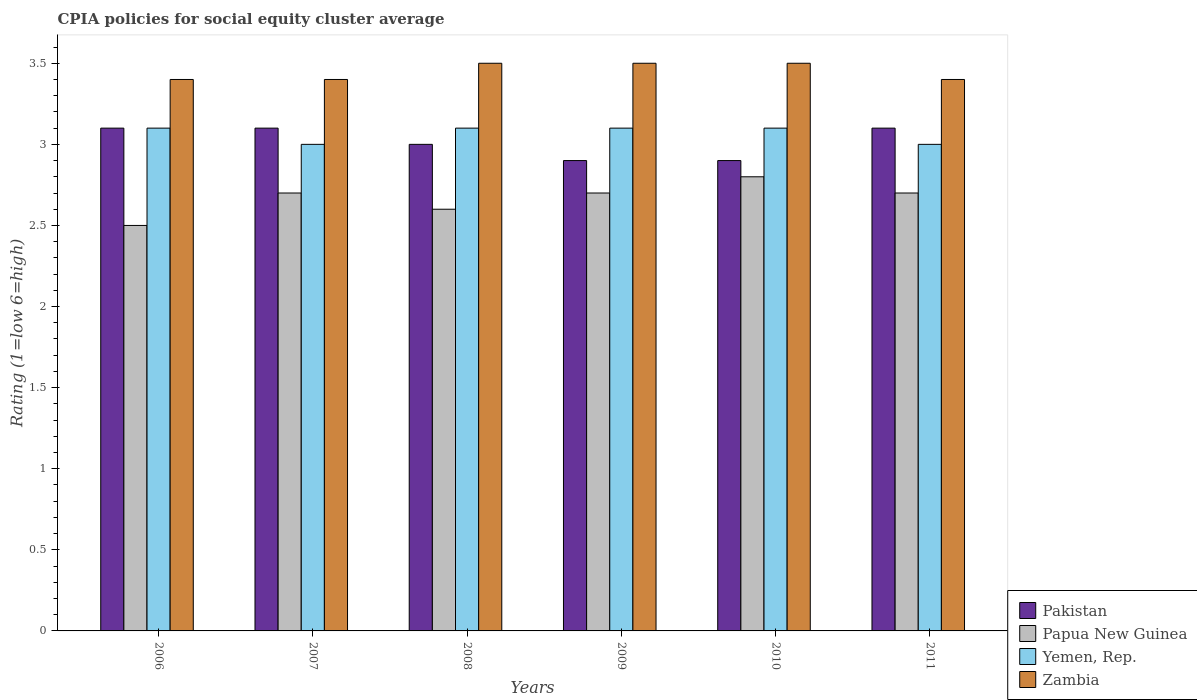How many different coloured bars are there?
Your response must be concise. 4. Are the number of bars per tick equal to the number of legend labels?
Ensure brevity in your answer.  Yes. How many bars are there on the 4th tick from the left?
Make the answer very short. 4. How many bars are there on the 3rd tick from the right?
Your answer should be very brief. 4. In how many cases, is the number of bars for a given year not equal to the number of legend labels?
Your answer should be very brief. 0. Across all years, what is the maximum CPIA rating in Zambia?
Offer a terse response. 3.5. In which year was the CPIA rating in Papua New Guinea minimum?
Keep it short and to the point. 2006. What is the total CPIA rating in Yemen, Rep. in the graph?
Offer a terse response. 18.4. What is the difference between the CPIA rating in Pakistan in 2011 and the CPIA rating in Papua New Guinea in 2009?
Ensure brevity in your answer.  0.4. What is the average CPIA rating in Papua New Guinea per year?
Your answer should be compact. 2.67. In the year 2008, what is the difference between the CPIA rating in Pakistan and CPIA rating in Papua New Guinea?
Your answer should be very brief. 0.4. In how many years, is the CPIA rating in Papua New Guinea greater than 3.5?
Give a very brief answer. 0. Is the CPIA rating in Yemen, Rep. in 2006 less than that in 2010?
Provide a succinct answer. No. Is the difference between the CPIA rating in Pakistan in 2008 and 2009 greater than the difference between the CPIA rating in Papua New Guinea in 2008 and 2009?
Offer a very short reply. Yes. What is the difference between the highest and the lowest CPIA rating in Zambia?
Your answer should be very brief. 0.1. What does the 1st bar from the left in 2006 represents?
Your answer should be compact. Pakistan. What does the 2nd bar from the right in 2006 represents?
Give a very brief answer. Yemen, Rep. How many bars are there?
Give a very brief answer. 24. What is the difference between two consecutive major ticks on the Y-axis?
Your response must be concise. 0.5. Are the values on the major ticks of Y-axis written in scientific E-notation?
Provide a succinct answer. No. Does the graph contain grids?
Provide a short and direct response. No. Where does the legend appear in the graph?
Your response must be concise. Bottom right. What is the title of the graph?
Make the answer very short. CPIA policies for social equity cluster average. What is the label or title of the Y-axis?
Provide a short and direct response. Rating (1=low 6=high). What is the Rating (1=low 6=high) in Papua New Guinea in 2006?
Your answer should be compact. 2.5. What is the Rating (1=low 6=high) in Zambia in 2006?
Your answer should be compact. 3.4. What is the Rating (1=low 6=high) in Pakistan in 2007?
Provide a succinct answer. 3.1. What is the Rating (1=low 6=high) of Papua New Guinea in 2007?
Your answer should be very brief. 2.7. What is the Rating (1=low 6=high) of Yemen, Rep. in 2007?
Offer a terse response. 3. What is the Rating (1=low 6=high) in Zambia in 2007?
Offer a very short reply. 3.4. What is the Rating (1=low 6=high) of Pakistan in 2008?
Keep it short and to the point. 3. What is the Rating (1=low 6=high) of Yemen, Rep. in 2010?
Provide a succinct answer. 3.1. What is the Rating (1=low 6=high) of Zambia in 2010?
Ensure brevity in your answer.  3.5. What is the Rating (1=low 6=high) in Yemen, Rep. in 2011?
Give a very brief answer. 3. What is the Rating (1=low 6=high) of Zambia in 2011?
Provide a short and direct response. 3.4. Across all years, what is the maximum Rating (1=low 6=high) of Zambia?
Provide a succinct answer. 3.5. Across all years, what is the minimum Rating (1=low 6=high) in Pakistan?
Your answer should be compact. 2.9. Across all years, what is the minimum Rating (1=low 6=high) of Papua New Guinea?
Offer a terse response. 2.5. Across all years, what is the minimum Rating (1=low 6=high) in Yemen, Rep.?
Offer a terse response. 3. What is the total Rating (1=low 6=high) of Yemen, Rep. in the graph?
Offer a terse response. 18.4. What is the total Rating (1=low 6=high) in Zambia in the graph?
Provide a short and direct response. 20.7. What is the difference between the Rating (1=low 6=high) of Pakistan in 2006 and that in 2007?
Keep it short and to the point. 0. What is the difference between the Rating (1=low 6=high) in Zambia in 2006 and that in 2007?
Ensure brevity in your answer.  0. What is the difference between the Rating (1=low 6=high) of Yemen, Rep. in 2006 and that in 2008?
Ensure brevity in your answer.  0. What is the difference between the Rating (1=low 6=high) in Zambia in 2006 and that in 2008?
Your answer should be very brief. -0.1. What is the difference between the Rating (1=low 6=high) of Pakistan in 2006 and that in 2009?
Offer a very short reply. 0.2. What is the difference between the Rating (1=low 6=high) in Zambia in 2006 and that in 2009?
Provide a succinct answer. -0.1. What is the difference between the Rating (1=low 6=high) in Yemen, Rep. in 2006 and that in 2010?
Provide a succinct answer. 0. What is the difference between the Rating (1=low 6=high) in Pakistan in 2006 and that in 2011?
Provide a short and direct response. 0. What is the difference between the Rating (1=low 6=high) in Papua New Guinea in 2006 and that in 2011?
Keep it short and to the point. -0.2. What is the difference between the Rating (1=low 6=high) of Zambia in 2006 and that in 2011?
Ensure brevity in your answer.  0. What is the difference between the Rating (1=low 6=high) of Papua New Guinea in 2007 and that in 2008?
Give a very brief answer. 0.1. What is the difference between the Rating (1=low 6=high) of Yemen, Rep. in 2007 and that in 2008?
Your response must be concise. -0.1. What is the difference between the Rating (1=low 6=high) in Pakistan in 2007 and that in 2009?
Provide a succinct answer. 0.2. What is the difference between the Rating (1=low 6=high) of Yemen, Rep. in 2007 and that in 2009?
Ensure brevity in your answer.  -0.1. What is the difference between the Rating (1=low 6=high) of Pakistan in 2007 and that in 2010?
Your answer should be compact. 0.2. What is the difference between the Rating (1=low 6=high) of Papua New Guinea in 2007 and that in 2010?
Offer a terse response. -0.1. What is the difference between the Rating (1=low 6=high) in Yemen, Rep. in 2007 and that in 2011?
Your answer should be compact. 0. What is the difference between the Rating (1=low 6=high) in Yemen, Rep. in 2008 and that in 2009?
Make the answer very short. 0. What is the difference between the Rating (1=low 6=high) in Pakistan in 2008 and that in 2010?
Offer a very short reply. 0.1. What is the difference between the Rating (1=low 6=high) of Papua New Guinea in 2008 and that in 2010?
Your answer should be compact. -0.2. What is the difference between the Rating (1=low 6=high) of Papua New Guinea in 2008 and that in 2011?
Ensure brevity in your answer.  -0.1. What is the difference between the Rating (1=low 6=high) of Yemen, Rep. in 2008 and that in 2011?
Give a very brief answer. 0.1. What is the difference between the Rating (1=low 6=high) of Zambia in 2008 and that in 2011?
Your answer should be very brief. 0.1. What is the difference between the Rating (1=low 6=high) in Yemen, Rep. in 2009 and that in 2010?
Offer a very short reply. 0. What is the difference between the Rating (1=low 6=high) of Yemen, Rep. in 2009 and that in 2011?
Offer a very short reply. 0.1. What is the difference between the Rating (1=low 6=high) of Papua New Guinea in 2010 and that in 2011?
Your answer should be compact. 0.1. What is the difference between the Rating (1=low 6=high) of Papua New Guinea in 2006 and the Rating (1=low 6=high) of Yemen, Rep. in 2007?
Your response must be concise. -0.5. What is the difference between the Rating (1=low 6=high) in Pakistan in 2006 and the Rating (1=low 6=high) in Yemen, Rep. in 2008?
Keep it short and to the point. 0. What is the difference between the Rating (1=low 6=high) of Pakistan in 2006 and the Rating (1=low 6=high) of Zambia in 2008?
Your response must be concise. -0.4. What is the difference between the Rating (1=low 6=high) in Papua New Guinea in 2006 and the Rating (1=low 6=high) in Zambia in 2008?
Provide a succinct answer. -1. What is the difference between the Rating (1=low 6=high) of Yemen, Rep. in 2006 and the Rating (1=low 6=high) of Zambia in 2008?
Keep it short and to the point. -0.4. What is the difference between the Rating (1=low 6=high) in Pakistan in 2006 and the Rating (1=low 6=high) in Papua New Guinea in 2009?
Offer a terse response. 0.4. What is the difference between the Rating (1=low 6=high) in Pakistan in 2006 and the Rating (1=low 6=high) in Yemen, Rep. in 2009?
Ensure brevity in your answer.  0. What is the difference between the Rating (1=low 6=high) in Pakistan in 2006 and the Rating (1=low 6=high) in Zambia in 2009?
Ensure brevity in your answer.  -0.4. What is the difference between the Rating (1=low 6=high) of Papua New Guinea in 2006 and the Rating (1=low 6=high) of Yemen, Rep. in 2009?
Offer a terse response. -0.6. What is the difference between the Rating (1=low 6=high) of Papua New Guinea in 2006 and the Rating (1=low 6=high) of Zambia in 2009?
Offer a terse response. -1. What is the difference between the Rating (1=low 6=high) of Yemen, Rep. in 2006 and the Rating (1=low 6=high) of Zambia in 2009?
Provide a succinct answer. -0.4. What is the difference between the Rating (1=low 6=high) of Pakistan in 2006 and the Rating (1=low 6=high) of Yemen, Rep. in 2010?
Provide a succinct answer. 0. What is the difference between the Rating (1=low 6=high) of Papua New Guinea in 2006 and the Rating (1=low 6=high) of Yemen, Rep. in 2010?
Provide a succinct answer. -0.6. What is the difference between the Rating (1=low 6=high) of Papua New Guinea in 2006 and the Rating (1=low 6=high) of Zambia in 2010?
Make the answer very short. -1. What is the difference between the Rating (1=low 6=high) in Pakistan in 2006 and the Rating (1=low 6=high) in Yemen, Rep. in 2011?
Provide a succinct answer. 0.1. What is the difference between the Rating (1=low 6=high) of Yemen, Rep. in 2006 and the Rating (1=low 6=high) of Zambia in 2011?
Keep it short and to the point. -0.3. What is the difference between the Rating (1=low 6=high) in Pakistan in 2007 and the Rating (1=low 6=high) in Yemen, Rep. in 2008?
Make the answer very short. 0. What is the difference between the Rating (1=low 6=high) in Papua New Guinea in 2007 and the Rating (1=low 6=high) in Yemen, Rep. in 2008?
Offer a very short reply. -0.4. What is the difference between the Rating (1=low 6=high) of Papua New Guinea in 2007 and the Rating (1=low 6=high) of Zambia in 2008?
Offer a very short reply. -0.8. What is the difference between the Rating (1=low 6=high) of Yemen, Rep. in 2007 and the Rating (1=low 6=high) of Zambia in 2008?
Your answer should be compact. -0.5. What is the difference between the Rating (1=low 6=high) of Pakistan in 2007 and the Rating (1=low 6=high) of Papua New Guinea in 2009?
Your answer should be very brief. 0.4. What is the difference between the Rating (1=low 6=high) in Pakistan in 2007 and the Rating (1=low 6=high) in Yemen, Rep. in 2009?
Your answer should be compact. 0. What is the difference between the Rating (1=low 6=high) in Pakistan in 2007 and the Rating (1=low 6=high) in Zambia in 2009?
Your answer should be very brief. -0.4. What is the difference between the Rating (1=low 6=high) of Papua New Guinea in 2007 and the Rating (1=low 6=high) of Yemen, Rep. in 2009?
Provide a short and direct response. -0.4. What is the difference between the Rating (1=low 6=high) in Yemen, Rep. in 2007 and the Rating (1=low 6=high) in Zambia in 2009?
Make the answer very short. -0.5. What is the difference between the Rating (1=low 6=high) in Pakistan in 2007 and the Rating (1=low 6=high) in Yemen, Rep. in 2010?
Ensure brevity in your answer.  0. What is the difference between the Rating (1=low 6=high) of Yemen, Rep. in 2007 and the Rating (1=low 6=high) of Zambia in 2010?
Make the answer very short. -0.5. What is the difference between the Rating (1=low 6=high) in Pakistan in 2007 and the Rating (1=low 6=high) in Papua New Guinea in 2011?
Your response must be concise. 0.4. What is the difference between the Rating (1=low 6=high) of Pakistan in 2007 and the Rating (1=low 6=high) of Zambia in 2011?
Your response must be concise. -0.3. What is the difference between the Rating (1=low 6=high) in Papua New Guinea in 2007 and the Rating (1=low 6=high) in Zambia in 2011?
Provide a succinct answer. -0.7. What is the difference between the Rating (1=low 6=high) of Pakistan in 2008 and the Rating (1=low 6=high) of Papua New Guinea in 2009?
Ensure brevity in your answer.  0.3. What is the difference between the Rating (1=low 6=high) in Pakistan in 2008 and the Rating (1=low 6=high) in Zambia in 2009?
Provide a short and direct response. -0.5. What is the difference between the Rating (1=low 6=high) of Papua New Guinea in 2008 and the Rating (1=low 6=high) of Yemen, Rep. in 2009?
Your answer should be compact. -0.5. What is the difference between the Rating (1=low 6=high) in Papua New Guinea in 2008 and the Rating (1=low 6=high) in Zambia in 2009?
Offer a very short reply. -0.9. What is the difference between the Rating (1=low 6=high) of Yemen, Rep. in 2008 and the Rating (1=low 6=high) of Zambia in 2009?
Give a very brief answer. -0.4. What is the difference between the Rating (1=low 6=high) in Pakistan in 2008 and the Rating (1=low 6=high) in Papua New Guinea in 2010?
Your response must be concise. 0.2. What is the difference between the Rating (1=low 6=high) of Pakistan in 2008 and the Rating (1=low 6=high) of Yemen, Rep. in 2010?
Provide a succinct answer. -0.1. What is the difference between the Rating (1=low 6=high) of Pakistan in 2008 and the Rating (1=low 6=high) of Zambia in 2010?
Keep it short and to the point. -0.5. What is the difference between the Rating (1=low 6=high) in Papua New Guinea in 2008 and the Rating (1=low 6=high) in Yemen, Rep. in 2010?
Provide a short and direct response. -0.5. What is the difference between the Rating (1=low 6=high) in Papua New Guinea in 2008 and the Rating (1=low 6=high) in Zambia in 2010?
Your answer should be very brief. -0.9. What is the difference between the Rating (1=low 6=high) in Yemen, Rep. in 2008 and the Rating (1=low 6=high) in Zambia in 2010?
Your answer should be very brief. -0.4. What is the difference between the Rating (1=low 6=high) of Pakistan in 2008 and the Rating (1=low 6=high) of Papua New Guinea in 2011?
Give a very brief answer. 0.3. What is the difference between the Rating (1=low 6=high) of Pakistan in 2008 and the Rating (1=low 6=high) of Zambia in 2011?
Offer a terse response. -0.4. What is the difference between the Rating (1=low 6=high) in Papua New Guinea in 2008 and the Rating (1=low 6=high) in Zambia in 2011?
Offer a terse response. -0.8. What is the difference between the Rating (1=low 6=high) of Pakistan in 2009 and the Rating (1=low 6=high) of Papua New Guinea in 2010?
Ensure brevity in your answer.  0.1. What is the difference between the Rating (1=low 6=high) of Pakistan in 2009 and the Rating (1=low 6=high) of Yemen, Rep. in 2010?
Your response must be concise. -0.2. What is the difference between the Rating (1=low 6=high) in Pakistan in 2009 and the Rating (1=low 6=high) in Zambia in 2010?
Offer a terse response. -0.6. What is the difference between the Rating (1=low 6=high) of Papua New Guinea in 2009 and the Rating (1=low 6=high) of Zambia in 2010?
Give a very brief answer. -0.8. What is the difference between the Rating (1=low 6=high) of Papua New Guinea in 2009 and the Rating (1=low 6=high) of Yemen, Rep. in 2011?
Offer a terse response. -0.3. What is the difference between the Rating (1=low 6=high) of Pakistan in 2010 and the Rating (1=low 6=high) of Zambia in 2011?
Offer a terse response. -0.5. What is the average Rating (1=low 6=high) in Pakistan per year?
Offer a very short reply. 3.02. What is the average Rating (1=low 6=high) of Papua New Guinea per year?
Keep it short and to the point. 2.67. What is the average Rating (1=low 6=high) of Yemen, Rep. per year?
Make the answer very short. 3.07. What is the average Rating (1=low 6=high) of Zambia per year?
Give a very brief answer. 3.45. In the year 2006, what is the difference between the Rating (1=low 6=high) in Pakistan and Rating (1=low 6=high) in Zambia?
Keep it short and to the point. -0.3. In the year 2006, what is the difference between the Rating (1=low 6=high) in Papua New Guinea and Rating (1=low 6=high) in Yemen, Rep.?
Your answer should be compact. -0.6. In the year 2006, what is the difference between the Rating (1=low 6=high) of Yemen, Rep. and Rating (1=low 6=high) of Zambia?
Give a very brief answer. -0.3. In the year 2008, what is the difference between the Rating (1=low 6=high) of Pakistan and Rating (1=low 6=high) of Papua New Guinea?
Give a very brief answer. 0.4. In the year 2008, what is the difference between the Rating (1=low 6=high) of Papua New Guinea and Rating (1=low 6=high) of Yemen, Rep.?
Offer a very short reply. -0.5. In the year 2008, what is the difference between the Rating (1=low 6=high) in Papua New Guinea and Rating (1=low 6=high) in Zambia?
Provide a succinct answer. -0.9. In the year 2008, what is the difference between the Rating (1=low 6=high) of Yemen, Rep. and Rating (1=low 6=high) of Zambia?
Your answer should be very brief. -0.4. In the year 2009, what is the difference between the Rating (1=low 6=high) of Pakistan and Rating (1=low 6=high) of Yemen, Rep.?
Offer a terse response. -0.2. In the year 2009, what is the difference between the Rating (1=low 6=high) in Pakistan and Rating (1=low 6=high) in Zambia?
Offer a very short reply. -0.6. In the year 2009, what is the difference between the Rating (1=low 6=high) of Papua New Guinea and Rating (1=low 6=high) of Yemen, Rep.?
Your answer should be very brief. -0.4. In the year 2009, what is the difference between the Rating (1=low 6=high) of Papua New Guinea and Rating (1=low 6=high) of Zambia?
Provide a short and direct response. -0.8. In the year 2009, what is the difference between the Rating (1=low 6=high) of Yemen, Rep. and Rating (1=low 6=high) of Zambia?
Your response must be concise. -0.4. In the year 2010, what is the difference between the Rating (1=low 6=high) of Pakistan and Rating (1=low 6=high) of Yemen, Rep.?
Offer a terse response. -0.2. In the year 2010, what is the difference between the Rating (1=low 6=high) of Pakistan and Rating (1=low 6=high) of Zambia?
Ensure brevity in your answer.  -0.6. In the year 2011, what is the difference between the Rating (1=low 6=high) of Pakistan and Rating (1=low 6=high) of Yemen, Rep.?
Offer a terse response. 0.1. In the year 2011, what is the difference between the Rating (1=low 6=high) of Pakistan and Rating (1=low 6=high) of Zambia?
Provide a short and direct response. -0.3. In the year 2011, what is the difference between the Rating (1=low 6=high) of Papua New Guinea and Rating (1=low 6=high) of Zambia?
Your response must be concise. -0.7. What is the ratio of the Rating (1=low 6=high) of Papua New Guinea in 2006 to that in 2007?
Provide a short and direct response. 0.93. What is the ratio of the Rating (1=low 6=high) in Zambia in 2006 to that in 2007?
Give a very brief answer. 1. What is the ratio of the Rating (1=low 6=high) in Pakistan in 2006 to that in 2008?
Provide a short and direct response. 1.03. What is the ratio of the Rating (1=low 6=high) of Papua New Guinea in 2006 to that in 2008?
Offer a very short reply. 0.96. What is the ratio of the Rating (1=low 6=high) of Zambia in 2006 to that in 2008?
Provide a succinct answer. 0.97. What is the ratio of the Rating (1=low 6=high) in Pakistan in 2006 to that in 2009?
Your answer should be very brief. 1.07. What is the ratio of the Rating (1=low 6=high) in Papua New Guinea in 2006 to that in 2009?
Provide a short and direct response. 0.93. What is the ratio of the Rating (1=low 6=high) in Yemen, Rep. in 2006 to that in 2009?
Provide a succinct answer. 1. What is the ratio of the Rating (1=low 6=high) of Zambia in 2006 to that in 2009?
Offer a very short reply. 0.97. What is the ratio of the Rating (1=low 6=high) of Pakistan in 2006 to that in 2010?
Give a very brief answer. 1.07. What is the ratio of the Rating (1=low 6=high) of Papua New Guinea in 2006 to that in 2010?
Ensure brevity in your answer.  0.89. What is the ratio of the Rating (1=low 6=high) of Zambia in 2006 to that in 2010?
Your answer should be compact. 0.97. What is the ratio of the Rating (1=low 6=high) in Papua New Guinea in 2006 to that in 2011?
Give a very brief answer. 0.93. What is the ratio of the Rating (1=low 6=high) of Zambia in 2006 to that in 2011?
Your answer should be very brief. 1. What is the ratio of the Rating (1=low 6=high) of Papua New Guinea in 2007 to that in 2008?
Your answer should be very brief. 1.04. What is the ratio of the Rating (1=low 6=high) in Yemen, Rep. in 2007 to that in 2008?
Provide a succinct answer. 0.97. What is the ratio of the Rating (1=low 6=high) in Zambia in 2007 to that in 2008?
Make the answer very short. 0.97. What is the ratio of the Rating (1=low 6=high) in Pakistan in 2007 to that in 2009?
Provide a short and direct response. 1.07. What is the ratio of the Rating (1=low 6=high) in Papua New Guinea in 2007 to that in 2009?
Provide a succinct answer. 1. What is the ratio of the Rating (1=low 6=high) of Yemen, Rep. in 2007 to that in 2009?
Provide a short and direct response. 0.97. What is the ratio of the Rating (1=low 6=high) in Zambia in 2007 to that in 2009?
Your answer should be compact. 0.97. What is the ratio of the Rating (1=low 6=high) in Pakistan in 2007 to that in 2010?
Provide a succinct answer. 1.07. What is the ratio of the Rating (1=low 6=high) in Papua New Guinea in 2007 to that in 2010?
Your answer should be very brief. 0.96. What is the ratio of the Rating (1=low 6=high) of Yemen, Rep. in 2007 to that in 2010?
Provide a short and direct response. 0.97. What is the ratio of the Rating (1=low 6=high) of Zambia in 2007 to that in 2010?
Give a very brief answer. 0.97. What is the ratio of the Rating (1=low 6=high) of Pakistan in 2007 to that in 2011?
Ensure brevity in your answer.  1. What is the ratio of the Rating (1=low 6=high) in Zambia in 2007 to that in 2011?
Your answer should be compact. 1. What is the ratio of the Rating (1=low 6=high) in Pakistan in 2008 to that in 2009?
Provide a succinct answer. 1.03. What is the ratio of the Rating (1=low 6=high) in Yemen, Rep. in 2008 to that in 2009?
Your response must be concise. 1. What is the ratio of the Rating (1=low 6=high) in Pakistan in 2008 to that in 2010?
Offer a very short reply. 1.03. What is the ratio of the Rating (1=low 6=high) in Papua New Guinea in 2008 to that in 2010?
Provide a succinct answer. 0.93. What is the ratio of the Rating (1=low 6=high) of Zambia in 2008 to that in 2010?
Offer a very short reply. 1. What is the ratio of the Rating (1=low 6=high) of Pakistan in 2008 to that in 2011?
Offer a terse response. 0.97. What is the ratio of the Rating (1=low 6=high) of Papua New Guinea in 2008 to that in 2011?
Keep it short and to the point. 0.96. What is the ratio of the Rating (1=low 6=high) of Zambia in 2008 to that in 2011?
Your answer should be compact. 1.03. What is the ratio of the Rating (1=low 6=high) of Pakistan in 2009 to that in 2010?
Your response must be concise. 1. What is the ratio of the Rating (1=low 6=high) of Pakistan in 2009 to that in 2011?
Your answer should be very brief. 0.94. What is the ratio of the Rating (1=low 6=high) in Papua New Guinea in 2009 to that in 2011?
Your answer should be compact. 1. What is the ratio of the Rating (1=low 6=high) in Yemen, Rep. in 2009 to that in 2011?
Your response must be concise. 1.03. What is the ratio of the Rating (1=low 6=high) of Zambia in 2009 to that in 2011?
Give a very brief answer. 1.03. What is the ratio of the Rating (1=low 6=high) in Pakistan in 2010 to that in 2011?
Keep it short and to the point. 0.94. What is the ratio of the Rating (1=low 6=high) of Zambia in 2010 to that in 2011?
Make the answer very short. 1.03. What is the difference between the highest and the second highest Rating (1=low 6=high) of Papua New Guinea?
Keep it short and to the point. 0.1. What is the difference between the highest and the second highest Rating (1=low 6=high) of Zambia?
Your answer should be compact. 0. What is the difference between the highest and the lowest Rating (1=low 6=high) of Pakistan?
Offer a terse response. 0.2. What is the difference between the highest and the lowest Rating (1=low 6=high) in Yemen, Rep.?
Give a very brief answer. 0.1. What is the difference between the highest and the lowest Rating (1=low 6=high) of Zambia?
Offer a terse response. 0.1. 